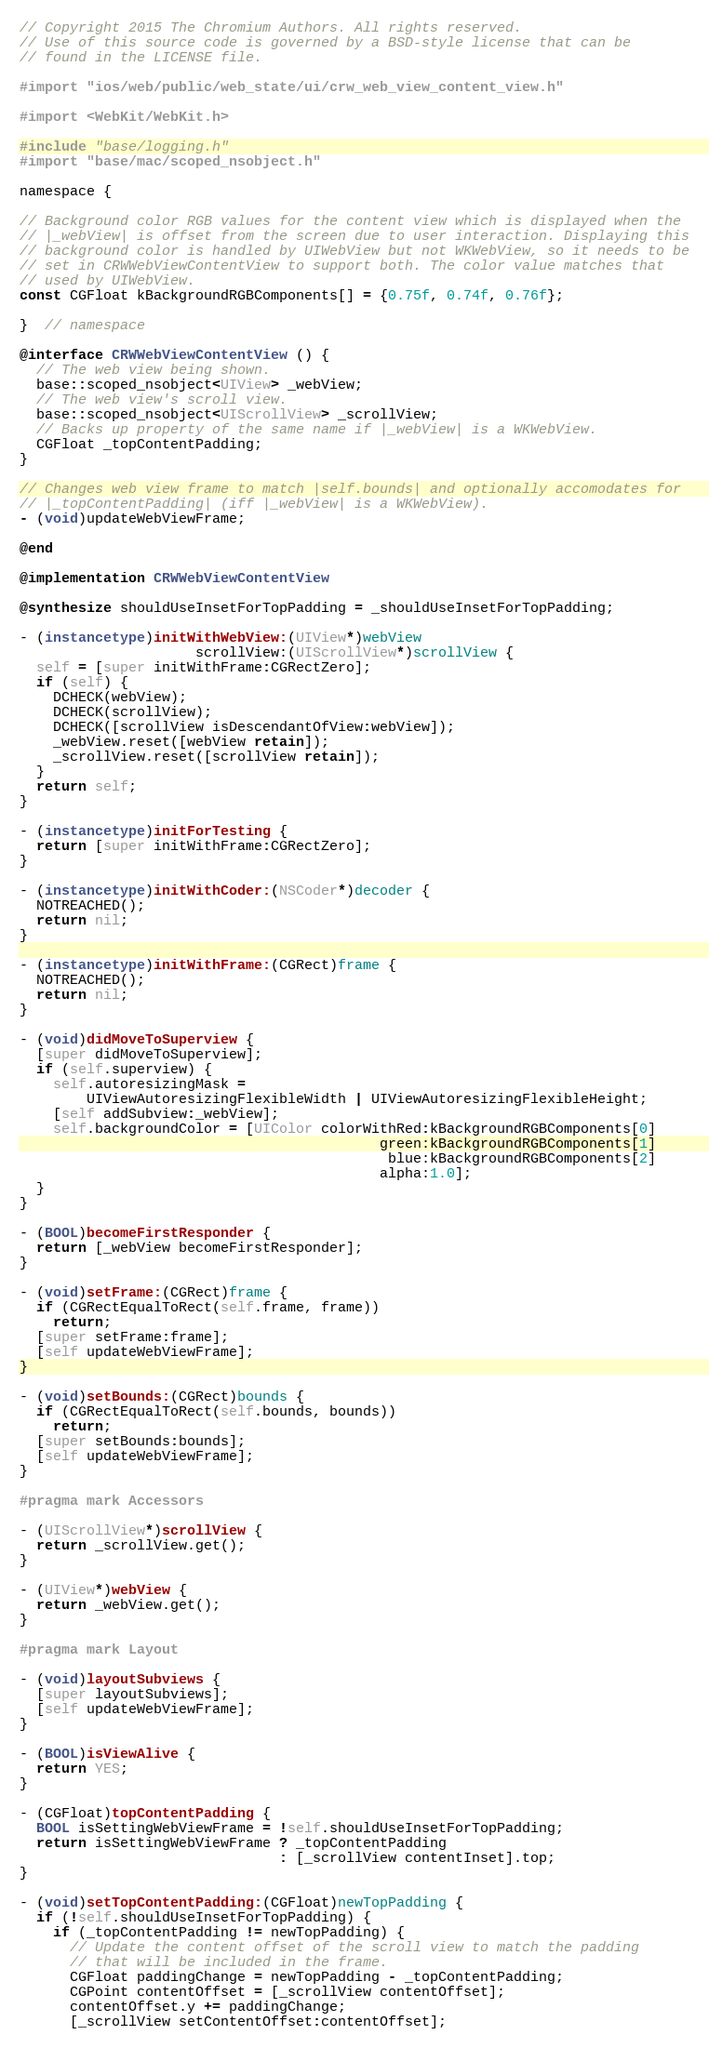<code> <loc_0><loc_0><loc_500><loc_500><_ObjectiveC_>// Copyright 2015 The Chromium Authors. All rights reserved.
// Use of this source code is governed by a BSD-style license that can be
// found in the LICENSE file.

#import "ios/web/public/web_state/ui/crw_web_view_content_view.h"

#import <WebKit/WebKit.h>

#include "base/logging.h"
#import "base/mac/scoped_nsobject.h"

namespace {

// Background color RGB values for the content view which is displayed when the
// |_webView| is offset from the screen due to user interaction. Displaying this
// background color is handled by UIWebView but not WKWebView, so it needs to be
// set in CRWWebViewContentView to support both. The color value matches that
// used by UIWebView.
const CGFloat kBackgroundRGBComponents[] = {0.75f, 0.74f, 0.76f};

}  // namespace

@interface CRWWebViewContentView () {
  // The web view being shown.
  base::scoped_nsobject<UIView> _webView;
  // The web view's scroll view.
  base::scoped_nsobject<UIScrollView> _scrollView;
  // Backs up property of the same name if |_webView| is a WKWebView.
  CGFloat _topContentPadding;
}

// Changes web view frame to match |self.bounds| and optionally accomodates for
// |_topContentPadding| (iff |_webView| is a WKWebView).
- (void)updateWebViewFrame;

@end

@implementation CRWWebViewContentView

@synthesize shouldUseInsetForTopPadding = _shouldUseInsetForTopPadding;

- (instancetype)initWithWebView:(UIView*)webView
                     scrollView:(UIScrollView*)scrollView {
  self = [super initWithFrame:CGRectZero];
  if (self) {
    DCHECK(webView);
    DCHECK(scrollView);
    DCHECK([scrollView isDescendantOfView:webView]);
    _webView.reset([webView retain]);
    _scrollView.reset([scrollView retain]);
  }
  return self;
}

- (instancetype)initForTesting {
  return [super initWithFrame:CGRectZero];
}

- (instancetype)initWithCoder:(NSCoder*)decoder {
  NOTREACHED();
  return nil;
}

- (instancetype)initWithFrame:(CGRect)frame {
  NOTREACHED();
  return nil;
}

- (void)didMoveToSuperview {
  [super didMoveToSuperview];
  if (self.superview) {
    self.autoresizingMask =
        UIViewAutoresizingFlexibleWidth | UIViewAutoresizingFlexibleHeight;
    [self addSubview:_webView];
    self.backgroundColor = [UIColor colorWithRed:kBackgroundRGBComponents[0]
                                           green:kBackgroundRGBComponents[1]
                                            blue:kBackgroundRGBComponents[2]
                                           alpha:1.0];
  }
}

- (BOOL)becomeFirstResponder {
  return [_webView becomeFirstResponder];
}

- (void)setFrame:(CGRect)frame {
  if (CGRectEqualToRect(self.frame, frame))
    return;
  [super setFrame:frame];
  [self updateWebViewFrame];
}

- (void)setBounds:(CGRect)bounds {
  if (CGRectEqualToRect(self.bounds, bounds))
    return;
  [super setBounds:bounds];
  [self updateWebViewFrame];
}

#pragma mark Accessors

- (UIScrollView*)scrollView {
  return _scrollView.get();
}

- (UIView*)webView {
  return _webView.get();
}

#pragma mark Layout

- (void)layoutSubviews {
  [super layoutSubviews];
  [self updateWebViewFrame];
}

- (BOOL)isViewAlive {
  return YES;
}

- (CGFloat)topContentPadding {
  BOOL isSettingWebViewFrame = !self.shouldUseInsetForTopPadding;
  return isSettingWebViewFrame ? _topContentPadding
                               : [_scrollView contentInset].top;
}

- (void)setTopContentPadding:(CGFloat)newTopPadding {
  if (!self.shouldUseInsetForTopPadding) {
    if (_topContentPadding != newTopPadding) {
      // Update the content offset of the scroll view to match the padding
      // that will be included in the frame.
      CGFloat paddingChange = newTopPadding - _topContentPadding;
      CGPoint contentOffset = [_scrollView contentOffset];
      contentOffset.y += paddingChange;
      [_scrollView setContentOffset:contentOffset];</code> 